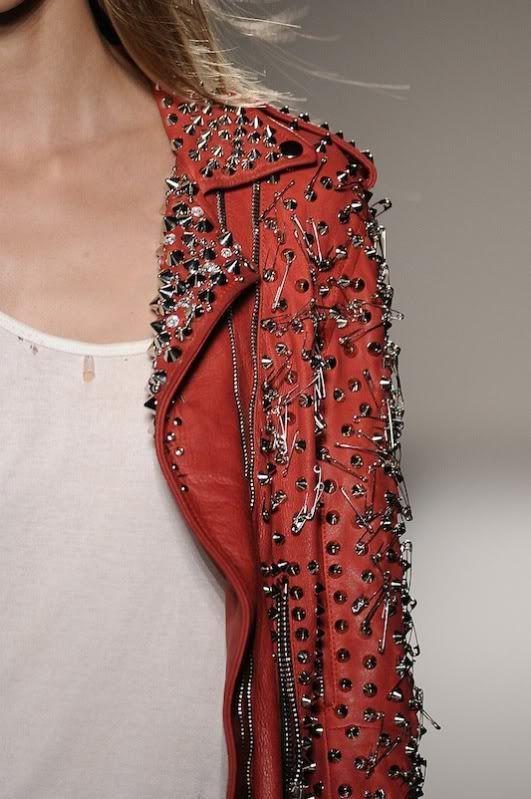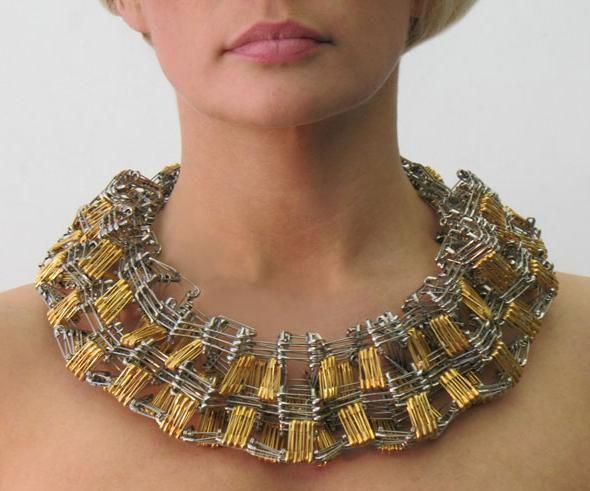The first image is the image on the left, the second image is the image on the right. Assess this claim about the two images: "An image features a jacket with an embellished studded lapel.". Correct or not? Answer yes or no. Yes. The first image is the image on the left, the second image is the image on the right. Analyze the images presented: Is the assertion "The jewelry in the image on the right is made from safety pins" valid? Answer yes or no. Yes. 